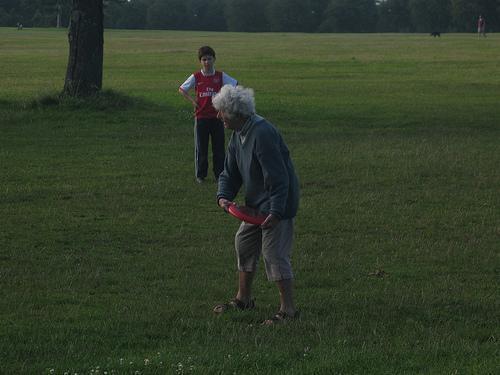How many people are in this picture?
Give a very brief answer. 2. How many legs does the lady have?
Give a very brief answer. 2. 